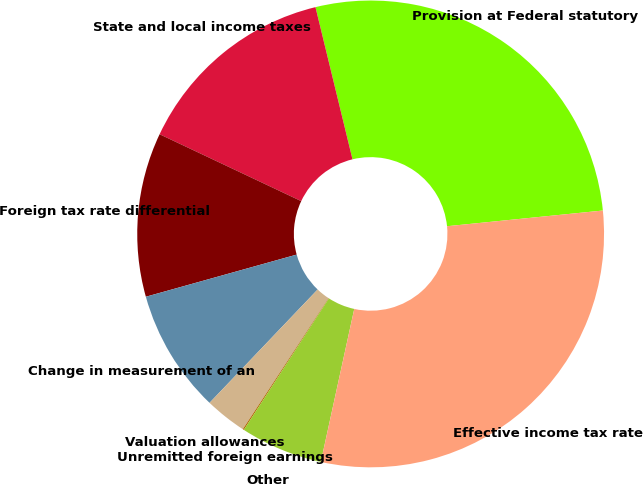Convert chart. <chart><loc_0><loc_0><loc_500><loc_500><pie_chart><fcel>Provision at Federal statutory<fcel>State and local income taxes<fcel>Foreign tax rate differential<fcel>Change in measurement of an<fcel>Valuation allowances<fcel>Unremitted foreign earnings<fcel>Other<fcel>Effective income tax rate<nl><fcel>27.2%<fcel>14.18%<fcel>11.36%<fcel>8.54%<fcel>2.9%<fcel>0.08%<fcel>5.72%<fcel>30.02%<nl></chart> 